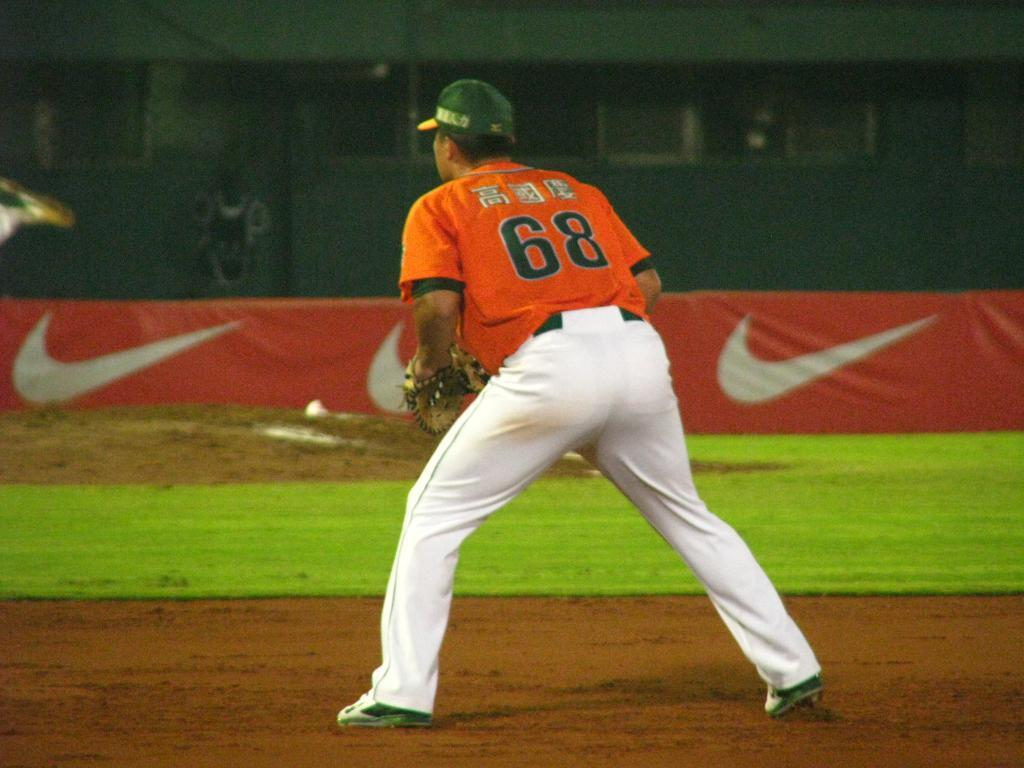<image>
Describe the image concisely. baseball player number 68 stands in front of a orange Nike banner 